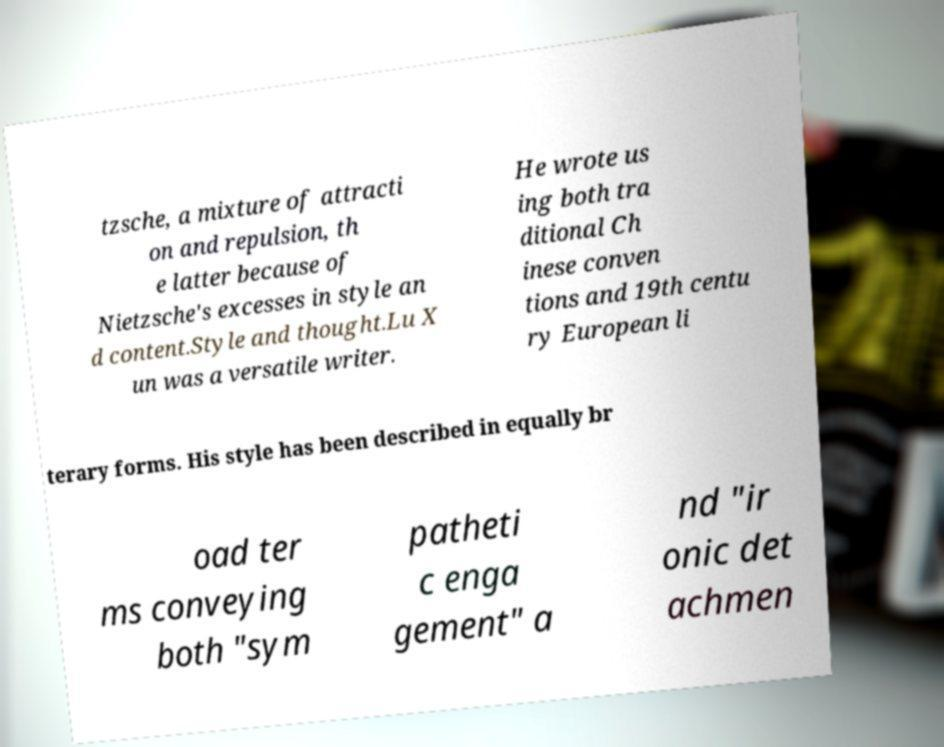Could you extract and type out the text from this image? tzsche, a mixture of attracti on and repulsion, th e latter because of Nietzsche's excesses in style an d content.Style and thought.Lu X un was a versatile writer. He wrote us ing both tra ditional Ch inese conven tions and 19th centu ry European li terary forms. His style has been described in equally br oad ter ms conveying both "sym patheti c enga gement" a nd "ir onic det achmen 